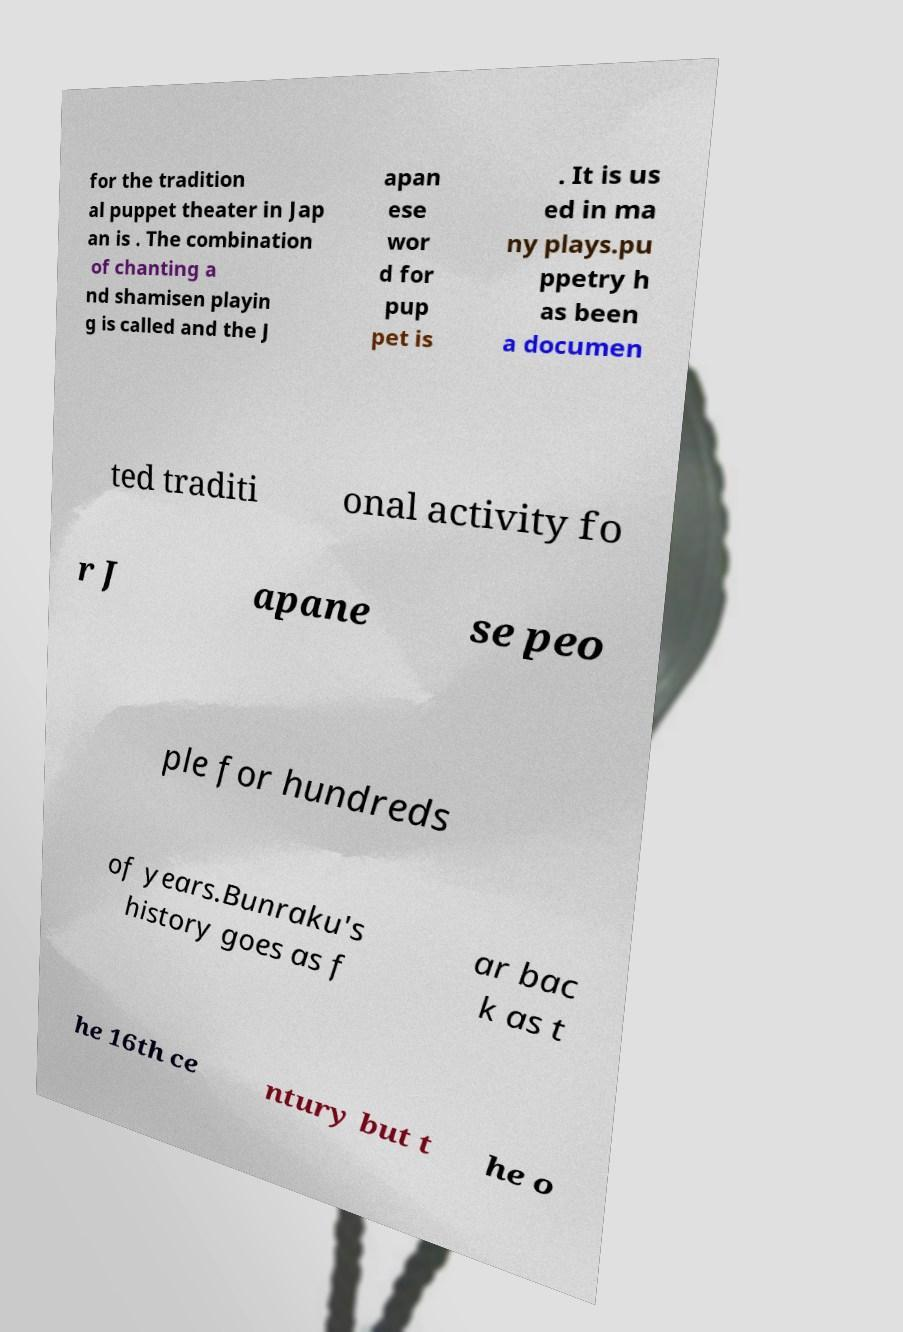For documentation purposes, I need the text within this image transcribed. Could you provide that? for the tradition al puppet theater in Jap an is . The combination of chanting a nd shamisen playin g is called and the J apan ese wor d for pup pet is . It is us ed in ma ny plays.pu ppetry h as been a documen ted traditi onal activity fo r J apane se peo ple for hundreds of years.Bunraku's history goes as f ar bac k as t he 16th ce ntury but t he o 